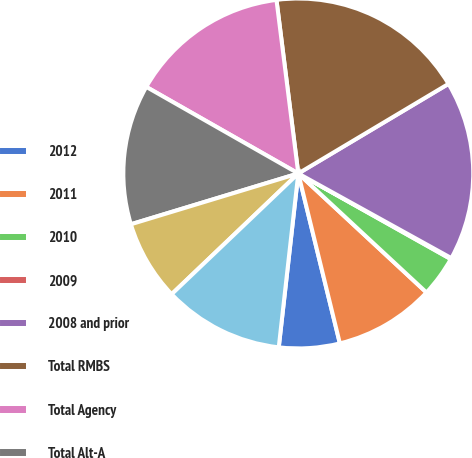Convert chart to OTSL. <chart><loc_0><loc_0><loc_500><loc_500><pie_chart><fcel>2012<fcel>2011<fcel>2010<fcel>2009<fcel>2008 and prior<fcel>Total RMBS<fcel>Total Agency<fcel>Total Alt-A<fcel>Total Subprime<fcel>Total Prime non-agency<nl><fcel>5.6%<fcel>9.27%<fcel>3.77%<fcel>0.1%<fcel>16.6%<fcel>18.43%<fcel>14.77%<fcel>12.93%<fcel>7.43%<fcel>11.1%<nl></chart> 